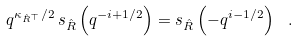Convert formula to latex. <formula><loc_0><loc_0><loc_500><loc_500>q ^ { \kappa _ { \hat { R } ^ { \top } } / 2 } \, s _ { \hat { R } } \left ( q ^ { - i + { 1 } / { 2 } } \right ) = s _ { \hat { R } } \left ( - q ^ { i - { 1 } / { 2 } } \right ) \ .</formula> 